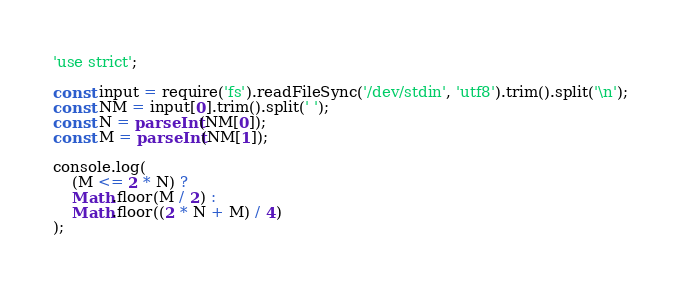Convert code to text. <code><loc_0><loc_0><loc_500><loc_500><_JavaScript_>'use strict';

const input = require('fs').readFileSync('/dev/stdin', 'utf8').trim().split('\n');
const NM = input[0].trim().split(' ');
const N = parseInt(NM[0]);
const M = parseInt(NM[1]);

console.log(
    (M <= 2 * N) ?
    Math.floor(M / 2) :
    Math.floor((2 * N + M) / 4)
);</code> 